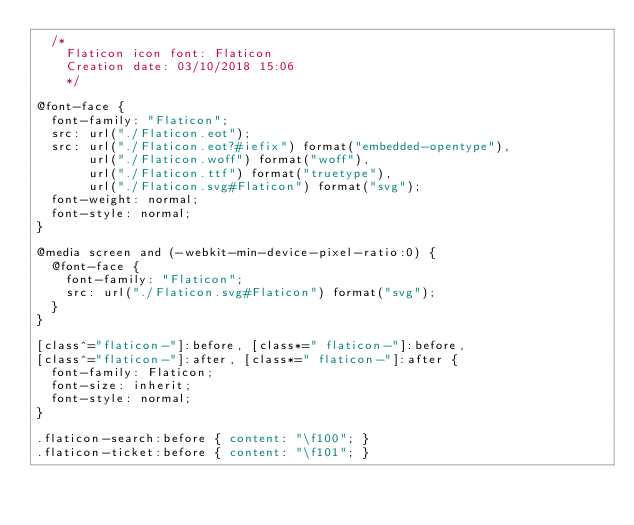<code> <loc_0><loc_0><loc_500><loc_500><_CSS_>	/*
  	Flaticon icon font: Flaticon
  	Creation date: 03/10/2018 15:06
  	*/

@font-face {
  font-family: "Flaticon";
  src: url("./Flaticon.eot");
  src: url("./Flaticon.eot?#iefix") format("embedded-opentype"),
       url("./Flaticon.woff") format("woff"),
       url("./Flaticon.ttf") format("truetype"),
       url("./Flaticon.svg#Flaticon") format("svg");
  font-weight: normal;
  font-style: normal;
}

@media screen and (-webkit-min-device-pixel-ratio:0) {
  @font-face {
    font-family: "Flaticon";
    src: url("./Flaticon.svg#Flaticon") format("svg");
  }
}

[class^="flaticon-"]:before, [class*=" flaticon-"]:before,
[class^="flaticon-"]:after, [class*=" flaticon-"]:after {   
  font-family: Flaticon;
  font-size: inherit;
  font-style: normal;
}

.flaticon-search:before { content: "\f100"; }
.flaticon-ticket:before { content: "\f101"; }</code> 